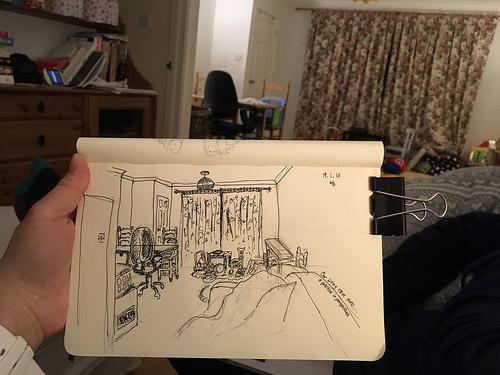<image>
Can you confirm if the room is in the room? Yes. The room is contained within or inside the room, showing a containment relationship. 